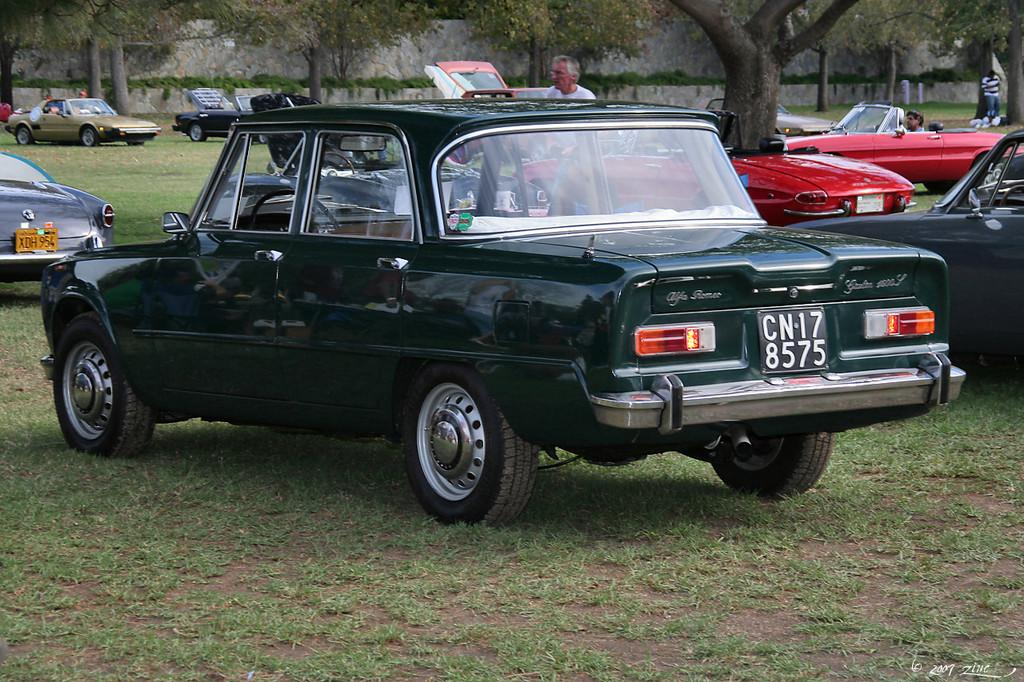What type of objects can be seen on the ground in the image? There are motor vehicles on the ground in the image. What else can be seen in the image besides the motor vehicles? There are persons standing in the image. What type of vegetation is visible in the background of the image? There are creepers and trees in the background of the image. What type of desk is visible in the image? There is no desk present in the image. What is the profit margin of the motor vehicles in the image? The image does not provide information about the profit margin of the motor vehicles. 